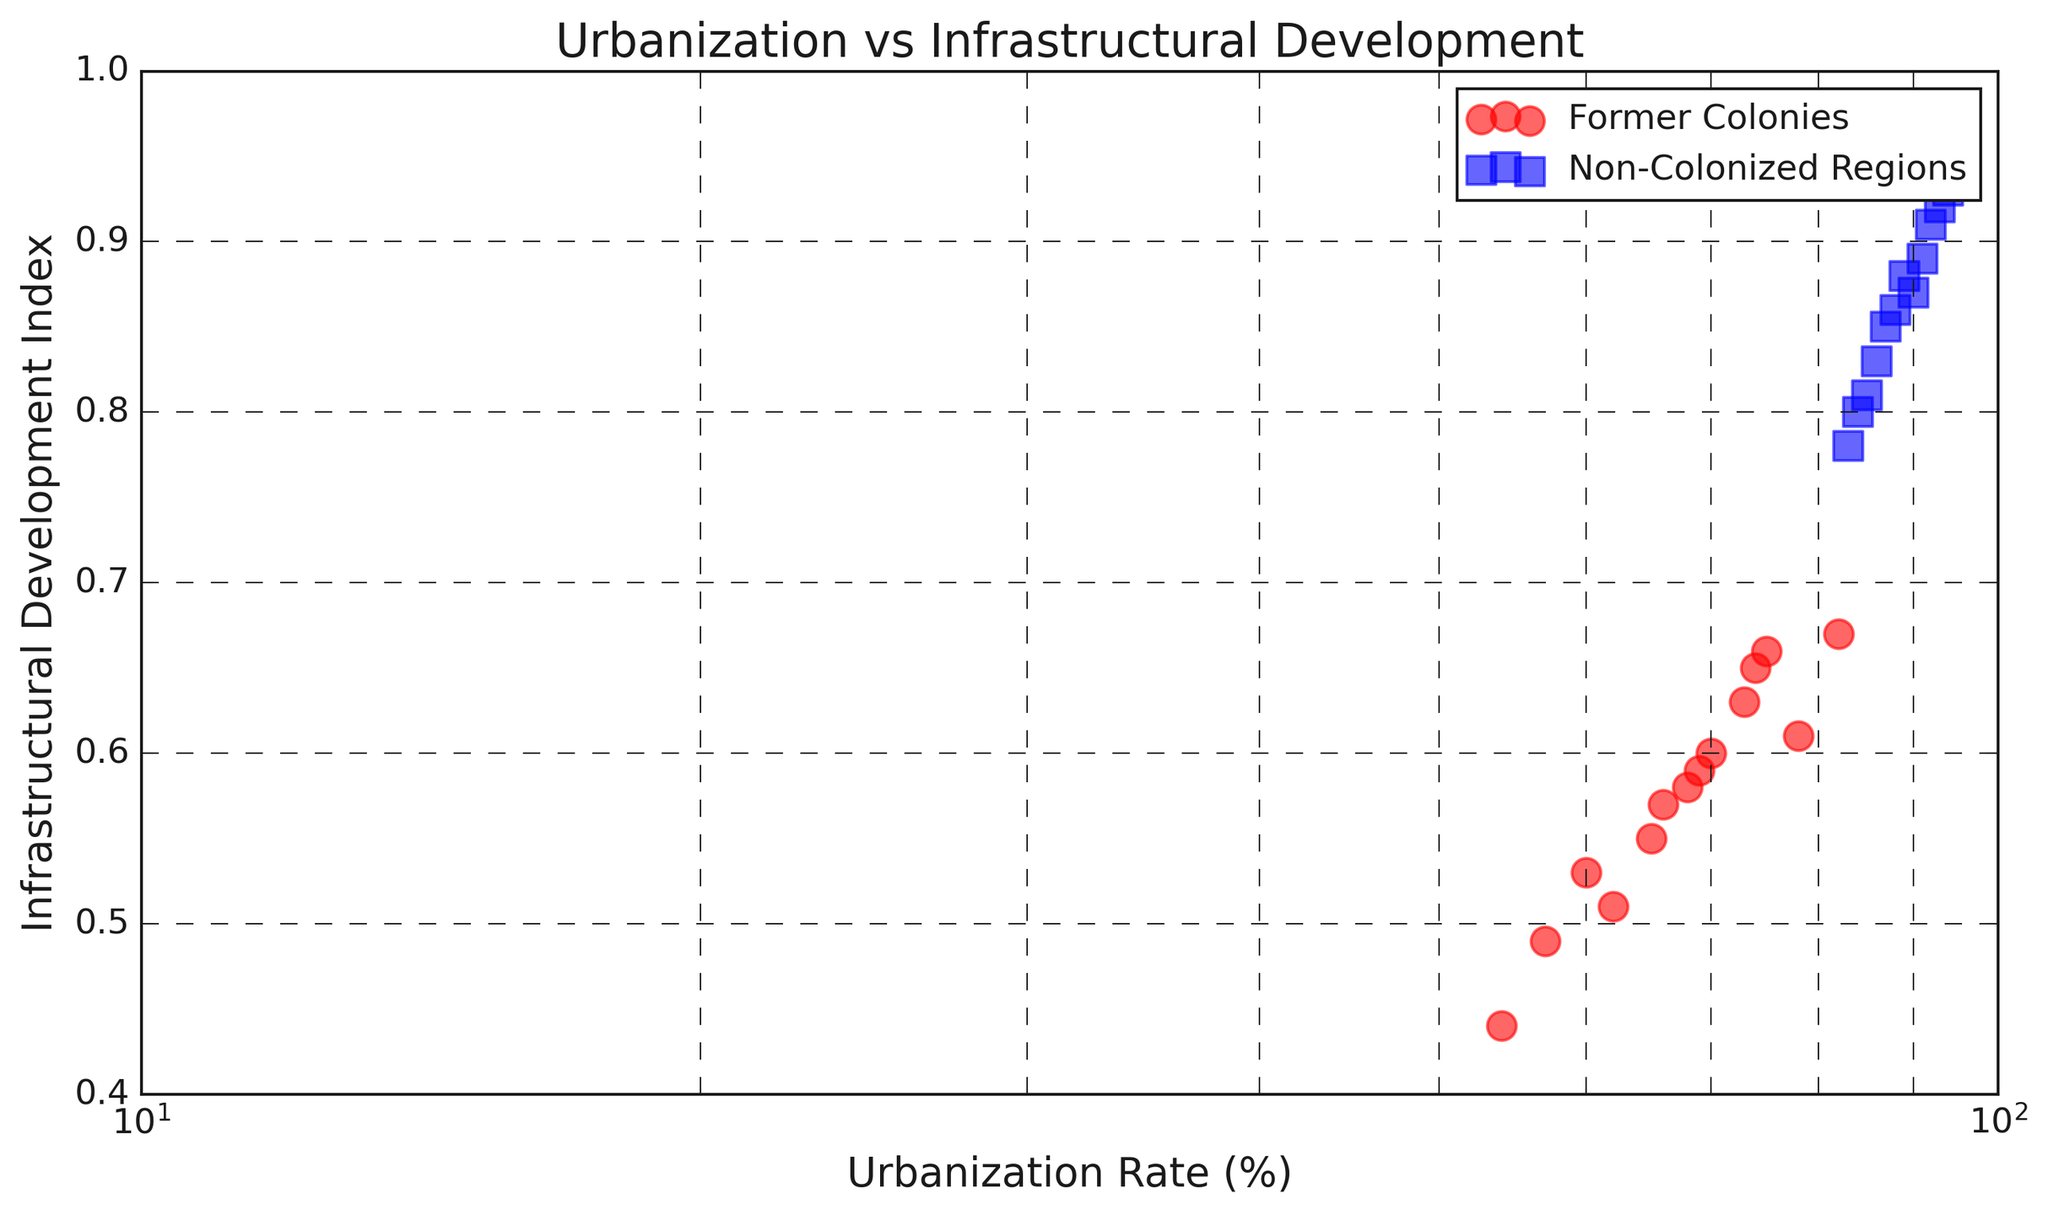What is the highest urbanization rate among former colonies? By inspecting the scatter plot, we can find the highest data point for former colonies on the x-axis. The former colony with the highest urbanization rate is located at 82%.
Answer: 82% Which group, former colonies or non-colonized regions, generally has higher infrastructural development? Observing the color distribution and average position of the points on the y-axis, the blue squares (non-colonized regions) are generally positioned higher, indicating better infrastructural development.
Answer: Non-colonized regions Are there any former colonies with an infrastructural development index higher than 0.65? Look for the red circles in the figure with a y-axis value greater than 0.65. There is no former colony with an infrastructural development index greater than 0.65.
Answer: No Which region has the lowest urbanization rate, and what is its infrastructural development index? Find the point with the smallest x-axis value in the scatter plot. The lowest urbanization rate is 54%, and it corresponds to an infrastructural development index of 0.44 for a former colony.
Answer: 54% and 0.44 Compare the urbanization rates between the highest infrastructural development former colony and non-colonized region. The highest infrastructural development index for former colonies is 0.67, corresponding to an urbanization rate of 82%. For non-colonized regions, the highest infrastructural development index is 0.93, which connects to an urbanization rate of 94%.
Answer: 82% vs 94% What is the average infrastructural development index for non-colonized regions? Sum the y-values (Infrastructural Development Index) of blue squares and divide by their count: (0.89 + 0.85 + 0.92 + 0.83 + 0.87 + 0.86 + 0.81 + 0.88 + 0.91 + 0.80 + 0.78 + 0.93) / 12 = 0.86.
Answer: 0.86 By how much does the urbanization rate of the region with the lowest infrastructural development index differ from the region with the highest development index? Identify the points with the minimum and maximum y-values. The lowest index for former colonies is 0.44 (urbanization rate 54%), and the highest for non-colonized regions is 0.93 (urbanization rate 94%). The difference is 94% - 54% = 40%.
Answer: 40% What is the median urbanization rate for non-colonized regions? Arrange the x-values (Urbanization Rates) of blue squares in ascending order and find the median. The sorted values are: 83, 84, 85, 86, 87, 88, 89, 90, 91, 92, 93, 94. The median is the average of 6th and 7th values: (88 + 89) / 2 = 88.5%.
Answer: 88.5% Do non-colonized regions show a consistent correlation between urbanization rate and infrastructural development index? By visually examining the scatter plot, we can determine that the blue squares follow a relatively consistent upward trend, indicating a positive correlation between urbanization rate and infrastructural development index for non-colonized regions.
Answer: Yes 